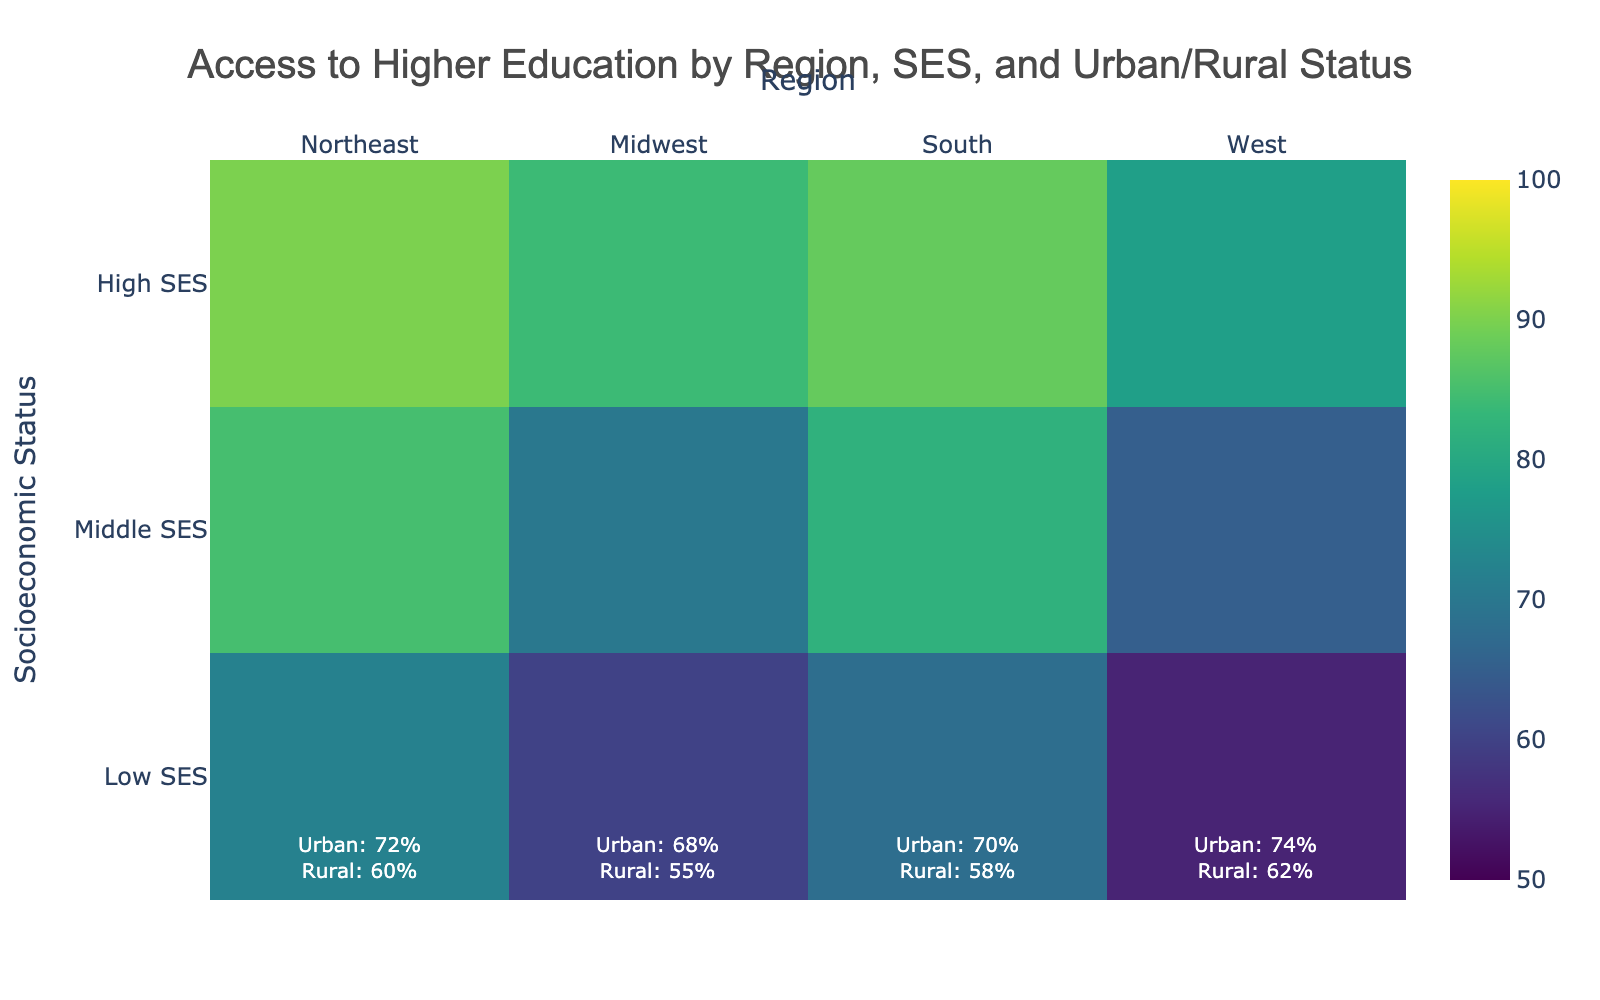What's the overall access to higher education for Low SES students in the Northeast region? To find the overall access to higher education for Low SES students in the Northeast region, we combine the urban and rural data points. From the heatmap, we see the values for Low SES in the Northeast are 72% for urban and 60% for rural.
Answer: 66% Which region has the highest access to higher education for High SES students? We need to check the values for High SES students across all regions. The values are Northeast: 90%, Midwest: 88%, South: 87%, and West: 91%. Thus, the West region has the highest access for High SES students.
Answer: West Compare the access to higher education between rural Low SES students in the South and Midwest regions. Which one is higher? For rural Low SES students, we need to compare South with a value of 58% and Midwest with a value of 55%. The South has the higher access.
Answer: South In which region do rural Middle SES students have the lowest access to higher education? We need to compare the rural Middle SES values across all regions. The values are Northeast: 70%, Midwest: 65%, South: 68%, and West: 74%. The Midwest has the lowest access.
Answer: Midwest What's the difference in access to higher education between urban and rural High SES students in the West region? We find the values for the High SES category in the West region, which are 91% for urban and 86% for rural. The difference is 91% - 86% = 5%.
Answer: 5% What is the range of access to higher education for Middle SES students across all regions? The range is calculated as the difference between the maximum and minimum values for Middle SES students across all regions. The values are Northeast: 85%, Midwest: 82%, South: 80%, and West: 87%. The range is 87% - 80% = 7%.
Answer: 7% Compare the access to higher education between urban Low SES students in the West and the South regions and state which is greater. The values for urban Low SES students are 74% in the West and 70% in the South. The West has greater access.
Answer: West Is there a region where the access to higher education is equal for rural Middle SES and rural High SES students? We need to check if any regions have the same value for rural Middle SES and rural High SES. None of the regions have equal values for those two categories.
Answer: No What is the average access to higher education for Low SES students across all regions? To find the average, sum all the Low SES values and divide by the number of regions. The values are 72, 60, 68, 55, 70, 58, 74, and 62. The sum is 519, and there are 8 values: 519 / 8 = 64.875%.
Answer: 64.875% 